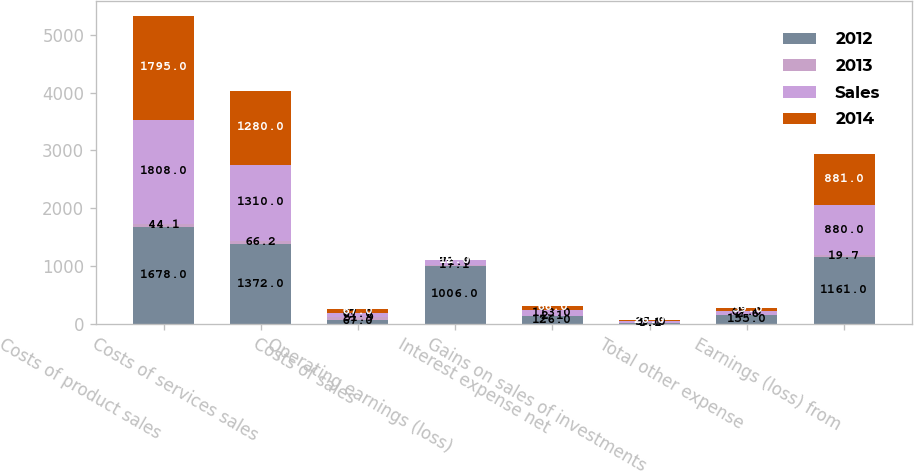Convert chart. <chart><loc_0><loc_0><loc_500><loc_500><stacked_bar_chart><ecel><fcel>Costs of product sales<fcel>Costs of services sales<fcel>Costs of sales<fcel>Operating earnings (loss)<fcel>Interest expense net<fcel>Gains on sales of investments<fcel>Total other expense<fcel>Earnings (loss) from<nl><fcel>2012<fcel>1678<fcel>1372<fcel>67<fcel>1006<fcel>126<fcel>5<fcel>155<fcel>1161<nl><fcel>2013<fcel>44.1<fcel>66.2<fcel>51.9<fcel>17.1<fcel>2.1<fcel>0.1<fcel>2.6<fcel>19.7<nl><fcel>Sales<fcel>1808<fcel>1310<fcel>67<fcel>71<fcel>113<fcel>37<fcel>67<fcel>880<nl><fcel>2014<fcel>1795<fcel>1280<fcel>67<fcel>12<fcel>66<fcel>26<fcel>39<fcel>881<nl></chart> 